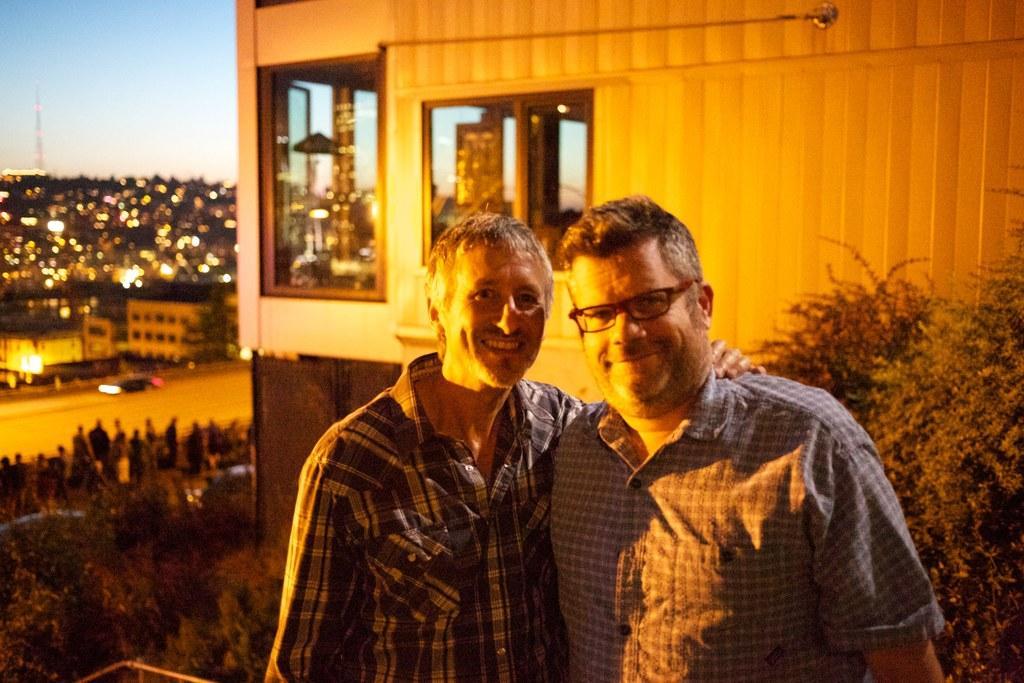In one or two sentences, can you explain what this image depicts? In this image there are two men in the middle. The man on the left side has kept his hand on the other man. Behind them there is a building with the glass windows. At the bottom there is a road on which there is a car and there are few people standing on the footpath. In the background there are so many buildings with the lights. At the top there is the sky. On the right side there are plants. 